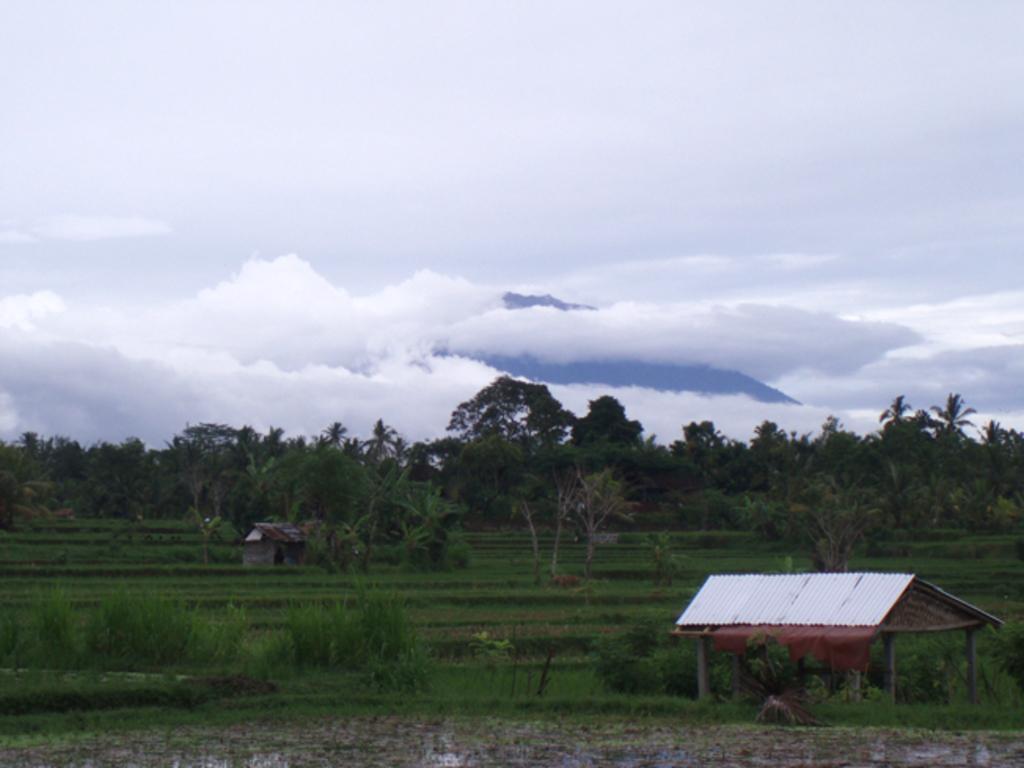Please provide a concise description of this image. In this image I can see a shed, background I can see grass and trees in green color and sky is in white and blue color. 